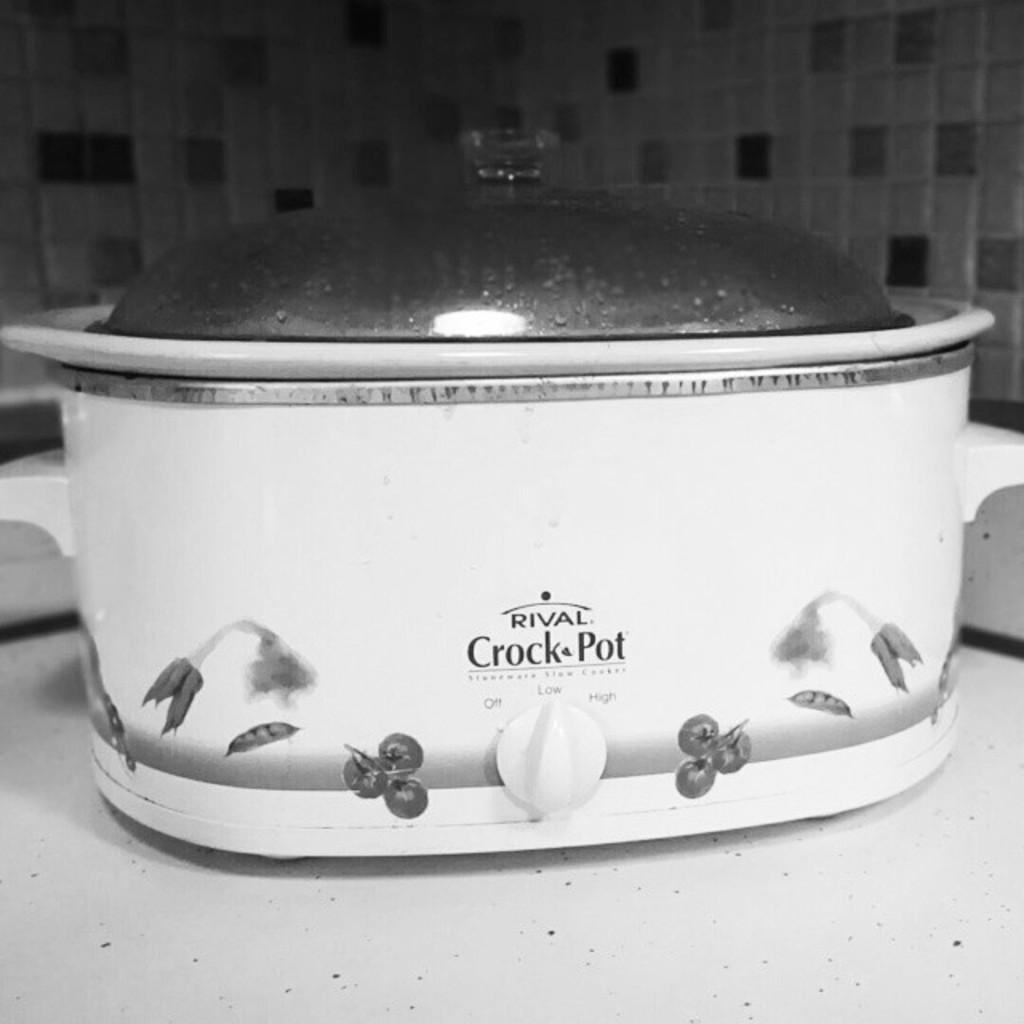Provide a one-sentence caption for the provided image. a pot that has the words crock pot on it. 